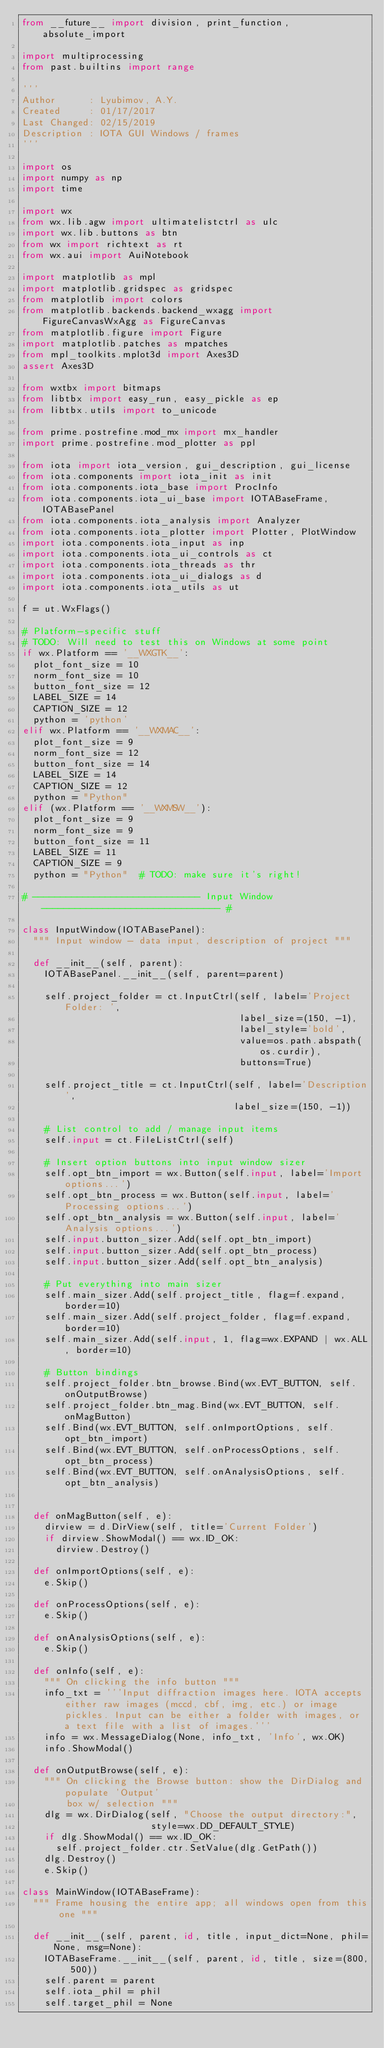Convert code to text. <code><loc_0><loc_0><loc_500><loc_500><_Python_>from __future__ import division, print_function, absolute_import

import multiprocessing
from past.builtins import range

'''
Author      : Lyubimov, A.Y.
Created     : 01/17/2017
Last Changed: 02/15/2019
Description : IOTA GUI Windows / frames
'''

import os
import numpy as np
import time

import wx
from wx.lib.agw import ultimatelistctrl as ulc
import wx.lib.buttons as btn
from wx import richtext as rt
from wx.aui import AuiNotebook

import matplotlib as mpl
import matplotlib.gridspec as gridspec
from matplotlib import colors
from matplotlib.backends.backend_wxagg import FigureCanvasWxAgg as FigureCanvas
from matplotlib.figure import Figure
import matplotlib.patches as mpatches
from mpl_toolkits.mplot3d import Axes3D
assert Axes3D

from wxtbx import bitmaps
from libtbx import easy_run, easy_pickle as ep
from libtbx.utils import to_unicode

from prime.postrefine.mod_mx import mx_handler
import prime.postrefine.mod_plotter as ppl

from iota import iota_version, gui_description, gui_license
from iota.components import iota_init as init
from iota.components.iota_base import ProcInfo
from iota.components.iota_ui_base import IOTABaseFrame, IOTABasePanel
from iota.components.iota_analysis import Analyzer
from iota.components.iota_plotter import Plotter, PlotWindow
import iota.components.iota_input as inp
import iota.components.iota_ui_controls as ct
import iota.components.iota_threads as thr
import iota.components.iota_ui_dialogs as d
import iota.components.iota_utils as ut

f = ut.WxFlags()

# Platform-specific stuff
# TODO: Will need to test this on Windows at some point
if wx.Platform == '__WXGTK__':
  plot_font_size = 10
  norm_font_size = 10
  button_font_size = 12
  LABEL_SIZE = 14
  CAPTION_SIZE = 12
  python = 'python'
elif wx.Platform == '__WXMAC__':
  plot_font_size = 9
  norm_font_size = 12
  button_font_size = 14
  LABEL_SIZE = 14
  CAPTION_SIZE = 12
  python = "Python"
elif (wx.Platform == '__WXMSW__'):
  plot_font_size = 9
  norm_font_size = 9
  button_font_size = 11
  LABEL_SIZE = 11
  CAPTION_SIZE = 9
  python = "Python"  # TODO: make sure it's right!

# ------------------------------ Input Window -------------------------------- #

class InputWindow(IOTABasePanel):
  """ Input window - data input, description of project """

  def __init__(self, parent):
    IOTABasePanel.__init__(self, parent=parent)

    self.project_folder = ct.InputCtrl(self, label='Project Folder: ',
                                       label_size=(150, -1),
                                       label_style='bold',
                                       value=os.path.abspath(os.curdir),
                                       buttons=True)

    self.project_title = ct.InputCtrl(self, label='Description',
                                      label_size=(150, -1))

    # List control to add / manage input items
    self.input = ct.FileListCtrl(self)

    # Insert option buttons into input window sizer
    self.opt_btn_import = wx.Button(self.input, label='Import options...')
    self.opt_btn_process = wx.Button(self.input, label='Processing options...')
    self.opt_btn_analysis = wx.Button(self.input, label='Analysis options...')
    self.input.button_sizer.Add(self.opt_btn_import)
    self.input.button_sizer.Add(self.opt_btn_process)
    self.input.button_sizer.Add(self.opt_btn_analysis)

    # Put everything into main sizer
    self.main_sizer.Add(self.project_title, flag=f.expand, border=10)
    self.main_sizer.Add(self.project_folder, flag=f.expand, border=10)
    self.main_sizer.Add(self.input, 1, flag=wx.EXPAND | wx.ALL, border=10)

    # Button bindings
    self.project_folder.btn_browse.Bind(wx.EVT_BUTTON, self.onOutputBrowse)
    self.project_folder.btn_mag.Bind(wx.EVT_BUTTON, self.onMagButton)
    self.Bind(wx.EVT_BUTTON, self.onImportOptions, self.opt_btn_import)
    self.Bind(wx.EVT_BUTTON, self.onProcessOptions, self.opt_btn_process)
    self.Bind(wx.EVT_BUTTON, self.onAnalysisOptions, self.opt_btn_analysis)


  def onMagButton(self, e):
    dirview = d.DirView(self, title='Current Folder')
    if dirview.ShowModal() == wx.ID_OK:
      dirview.Destroy()

  def onImportOptions(self, e):
    e.Skip()

  def onProcessOptions(self, e):
    e.Skip()

  def onAnalysisOptions(self, e):
    e.Skip()

  def onInfo(self, e):
    """ On clicking the info button """
    info_txt = '''Input diffraction images here. IOTA accepts either raw images (mccd, cbf, img, etc.) or image pickles. Input can be either a folder with images, or a text file with a list of images.'''
    info = wx.MessageDialog(None, info_txt, 'Info', wx.OK)
    info.ShowModal()

  def onOutputBrowse(self, e):
    """ On clicking the Browse button: show the DirDialog and populate 'Output'
        box w/ selection """
    dlg = wx.DirDialog(self, "Choose the output directory:",
                       style=wx.DD_DEFAULT_STYLE)
    if dlg.ShowModal() == wx.ID_OK:
      self.project_folder.ctr.SetValue(dlg.GetPath())
    dlg.Destroy()
    e.Skip()

class MainWindow(IOTABaseFrame):
  """ Frame housing the entire app; all windows open from this one """

  def __init__(self, parent, id, title, input_dict=None, phil=None, msg=None):
    IOTABaseFrame.__init__(self, parent, id, title, size=(800, 500))
    self.parent = parent
    self.iota_phil = phil
    self.target_phil = None</code> 